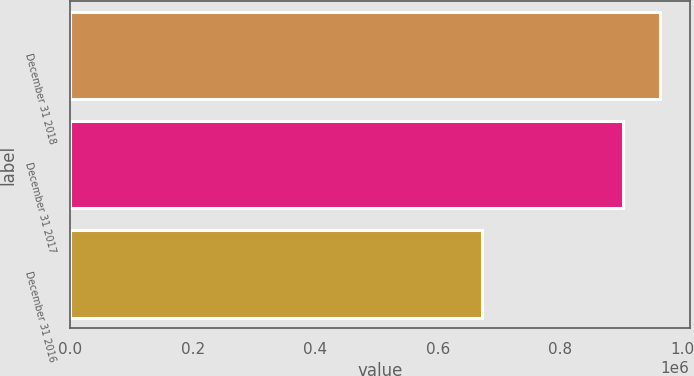Convert chart. <chart><loc_0><loc_0><loc_500><loc_500><bar_chart><fcel>December 31 2018<fcel>December 31 2017<fcel>December 31 2016<nl><fcel>963118<fcel>903373<fcel>673085<nl></chart> 